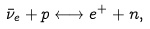Convert formula to latex. <formula><loc_0><loc_0><loc_500><loc_500>\bar { \nu } _ { e } + p \longleftrightarrow e ^ { + } + n ,</formula> 